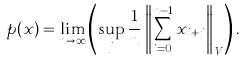Convert formula to latex. <formula><loc_0><loc_0><loc_500><loc_500>p ( x ) = \lim _ { n \rightarrow \infty } \left ( \sup _ { j } \frac { 1 } { n } \left \| \sum _ { i = 0 } ^ { n - 1 } x _ { i + j } \right \| _ { V } \right ) .</formula> 